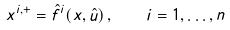<formula> <loc_0><loc_0><loc_500><loc_500>x ^ { i , + } = \hat { f } ^ { i } ( x , \hat { u } ) \, , \quad i = 1 , \dots , n</formula> 